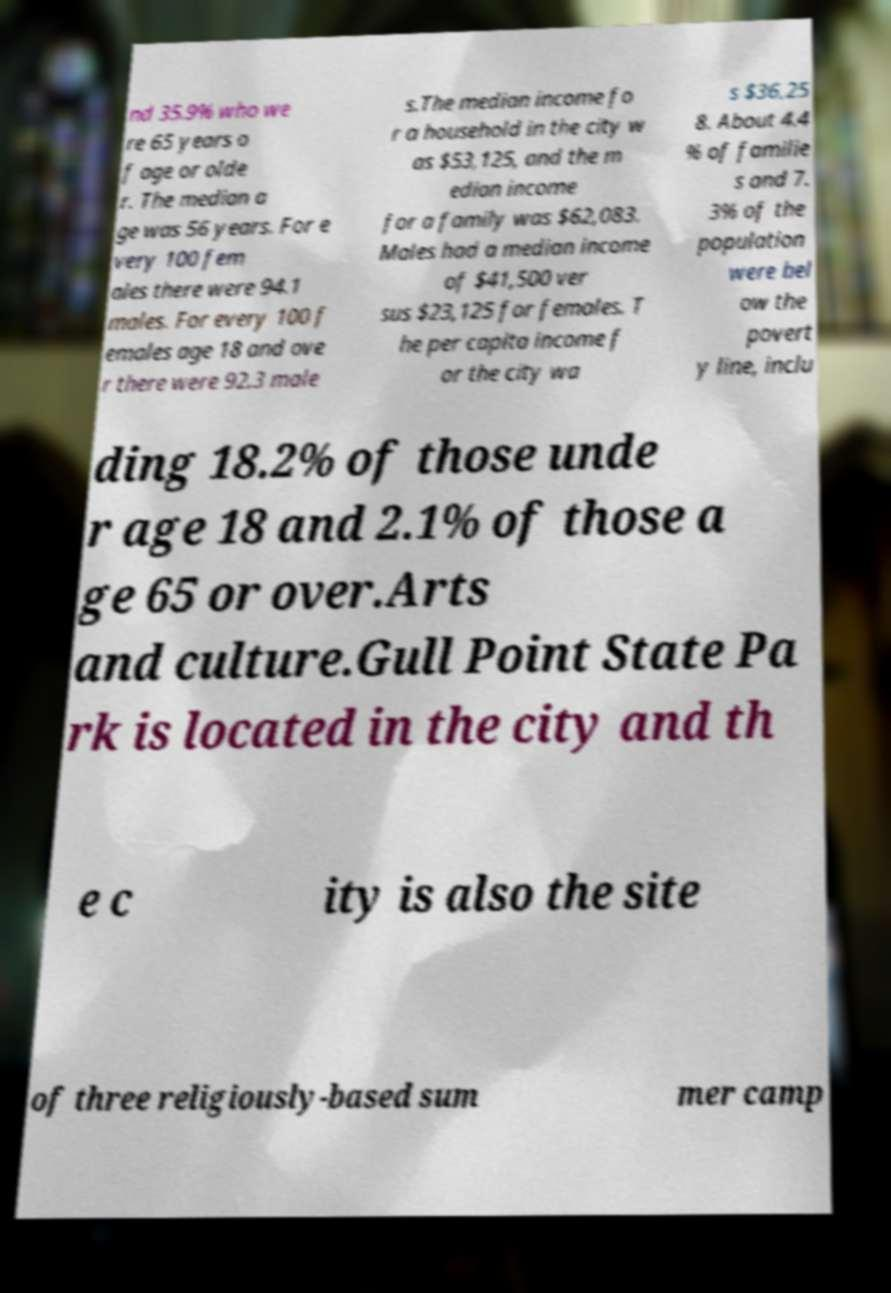Can you read and provide the text displayed in the image?This photo seems to have some interesting text. Can you extract and type it out for me? nd 35.9% who we re 65 years o f age or olde r. The median a ge was 56 years. For e very 100 fem ales there were 94.1 males. For every 100 f emales age 18 and ove r there were 92.3 male s.The median income fo r a household in the city w as $53,125, and the m edian income for a family was $62,083. Males had a median income of $41,500 ver sus $23,125 for females. T he per capita income f or the city wa s $36,25 8. About 4.4 % of familie s and 7. 3% of the population were bel ow the povert y line, inclu ding 18.2% of those unde r age 18 and 2.1% of those a ge 65 or over.Arts and culture.Gull Point State Pa rk is located in the city and th e c ity is also the site of three religiously-based sum mer camp 